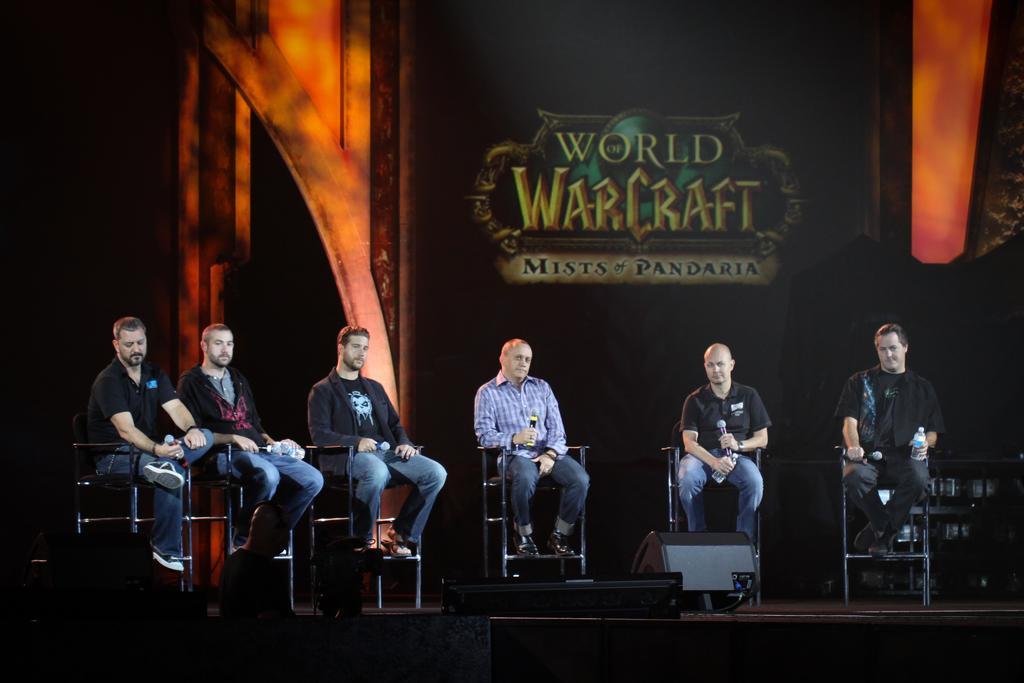Can you describe this image briefly? In this image I can see a group of people sitting on the chairs and holding a mic. They are wearing different color dress. Background is in black board and orange color. They are on the stage. 